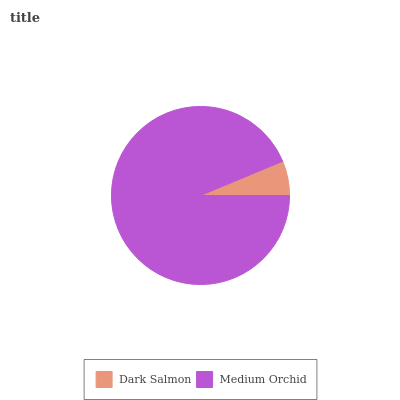Is Dark Salmon the minimum?
Answer yes or no. Yes. Is Medium Orchid the maximum?
Answer yes or no. Yes. Is Medium Orchid the minimum?
Answer yes or no. No. Is Medium Orchid greater than Dark Salmon?
Answer yes or no. Yes. Is Dark Salmon less than Medium Orchid?
Answer yes or no. Yes. Is Dark Salmon greater than Medium Orchid?
Answer yes or no. No. Is Medium Orchid less than Dark Salmon?
Answer yes or no. No. Is Medium Orchid the high median?
Answer yes or no. Yes. Is Dark Salmon the low median?
Answer yes or no. Yes. Is Dark Salmon the high median?
Answer yes or no. No. Is Medium Orchid the low median?
Answer yes or no. No. 